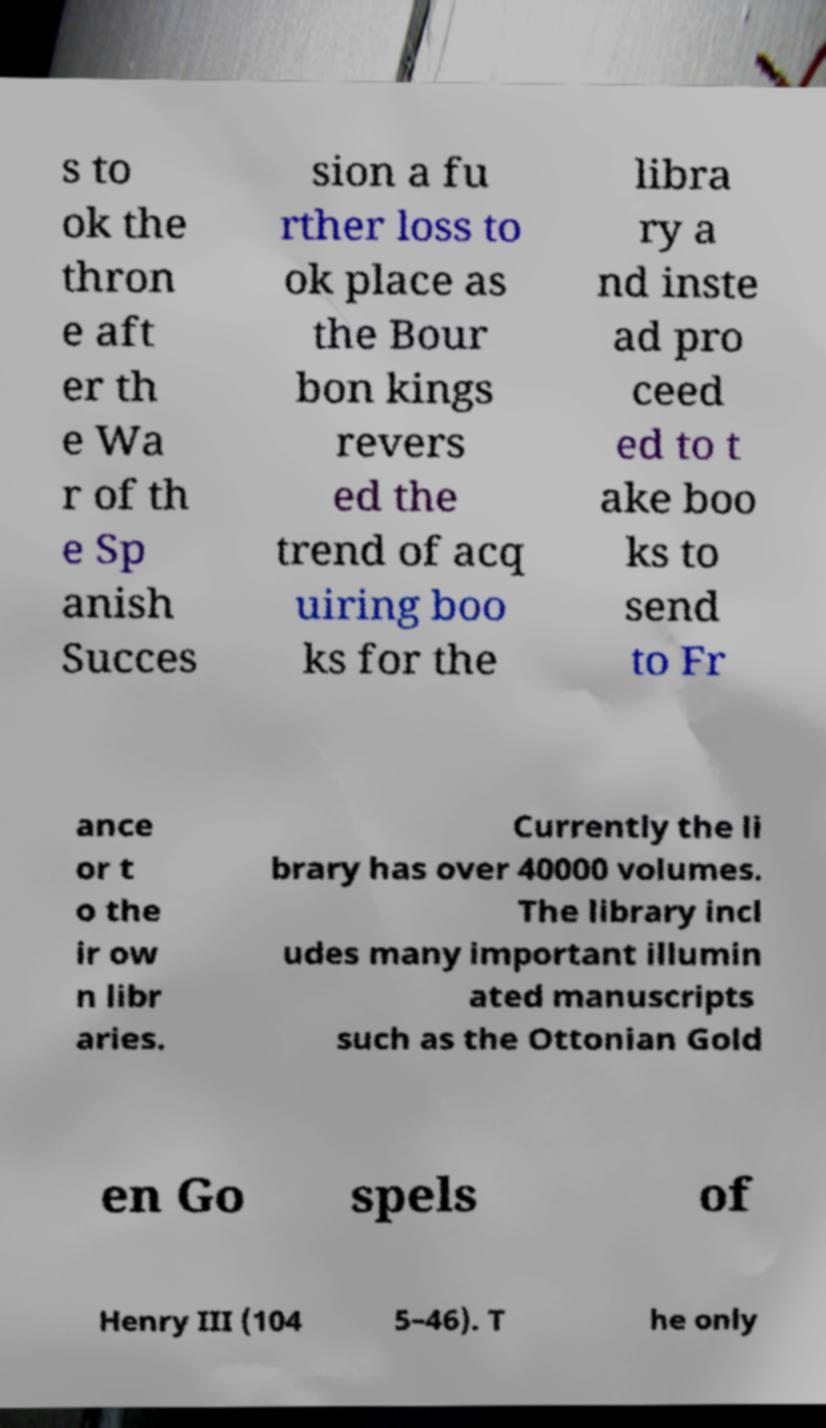Could you extract and type out the text from this image? s to ok the thron e aft er th e Wa r of th e Sp anish Succes sion a fu rther loss to ok place as the Bour bon kings revers ed the trend of acq uiring boo ks for the libra ry a nd inste ad pro ceed ed to t ake boo ks to send to Fr ance or t o the ir ow n libr aries. Currently the li brary has over 40000 volumes. The library incl udes many important illumin ated manuscripts such as the Ottonian Gold en Go spels of Henry III (104 5–46). T he only 